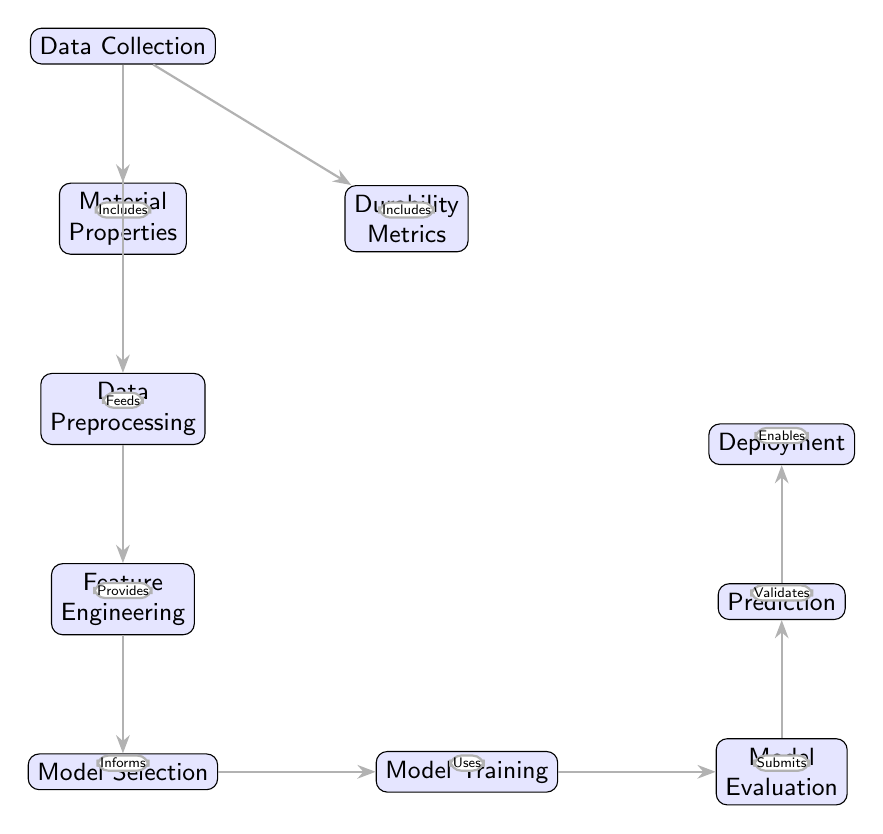What is the first step in the diagram? The diagram indicates that "Data Collection" is the first node in the flow, signifying it as the initial stage of the process.
Answer: Data Collection How many nodes are present in the diagram? By counting each labeled shape in the diagram, there are a total of eight distinct nodes listed in the workflow.
Answer: Eight What type of relationship exists between "Data Collection" and "Material Properties"? The diagram depicts a direct relationship where "Data Collection" includes "Material Properties," as illustrated by the connecting edge labeled "Includes."
Answer: Includes Which node follows "Model Selection"? According to the diagram, "Model Selection" directly connects to "Model Training," indicating that "Model Training" follows it in the sequence.
Answer: Model Training What is validated by the "Evaluation" node? The "Evaluation" node is explicitly connected to the "Prediction" node, and the label on the edge indicates that it validates the process of making predictions.
Answer: Prediction How does "Preprocessing" contribute to the overall process? The diagram shows that "Preprocessing" provides necessary data for "Feature Engineering," thereby playing a critical intermediary role in enhancing the feature set for the model.
Answer: Provides Which node is the final step in the process? The "Deployment" node is the last in the sequence, indicating it is the concluding step of the predictive analysis pipeline as seen in the flowchart.
Answer: Deployment What does the "Training" node utilize? The diagram specifies that the "Training" node uses the output from the "Model Selection" node to develop the predictive models.
Answer: Uses What is the primary function of the "Feature Engineering" node? Based on the flow, "Feature Engineering" informs the "Model Selection" process, implying its role is to enhance and select the relevant features utilized by the modeling stage.
Answer: Informs 